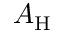Convert formula to latex. <formula><loc_0><loc_0><loc_500><loc_500>A _ { H }</formula> 